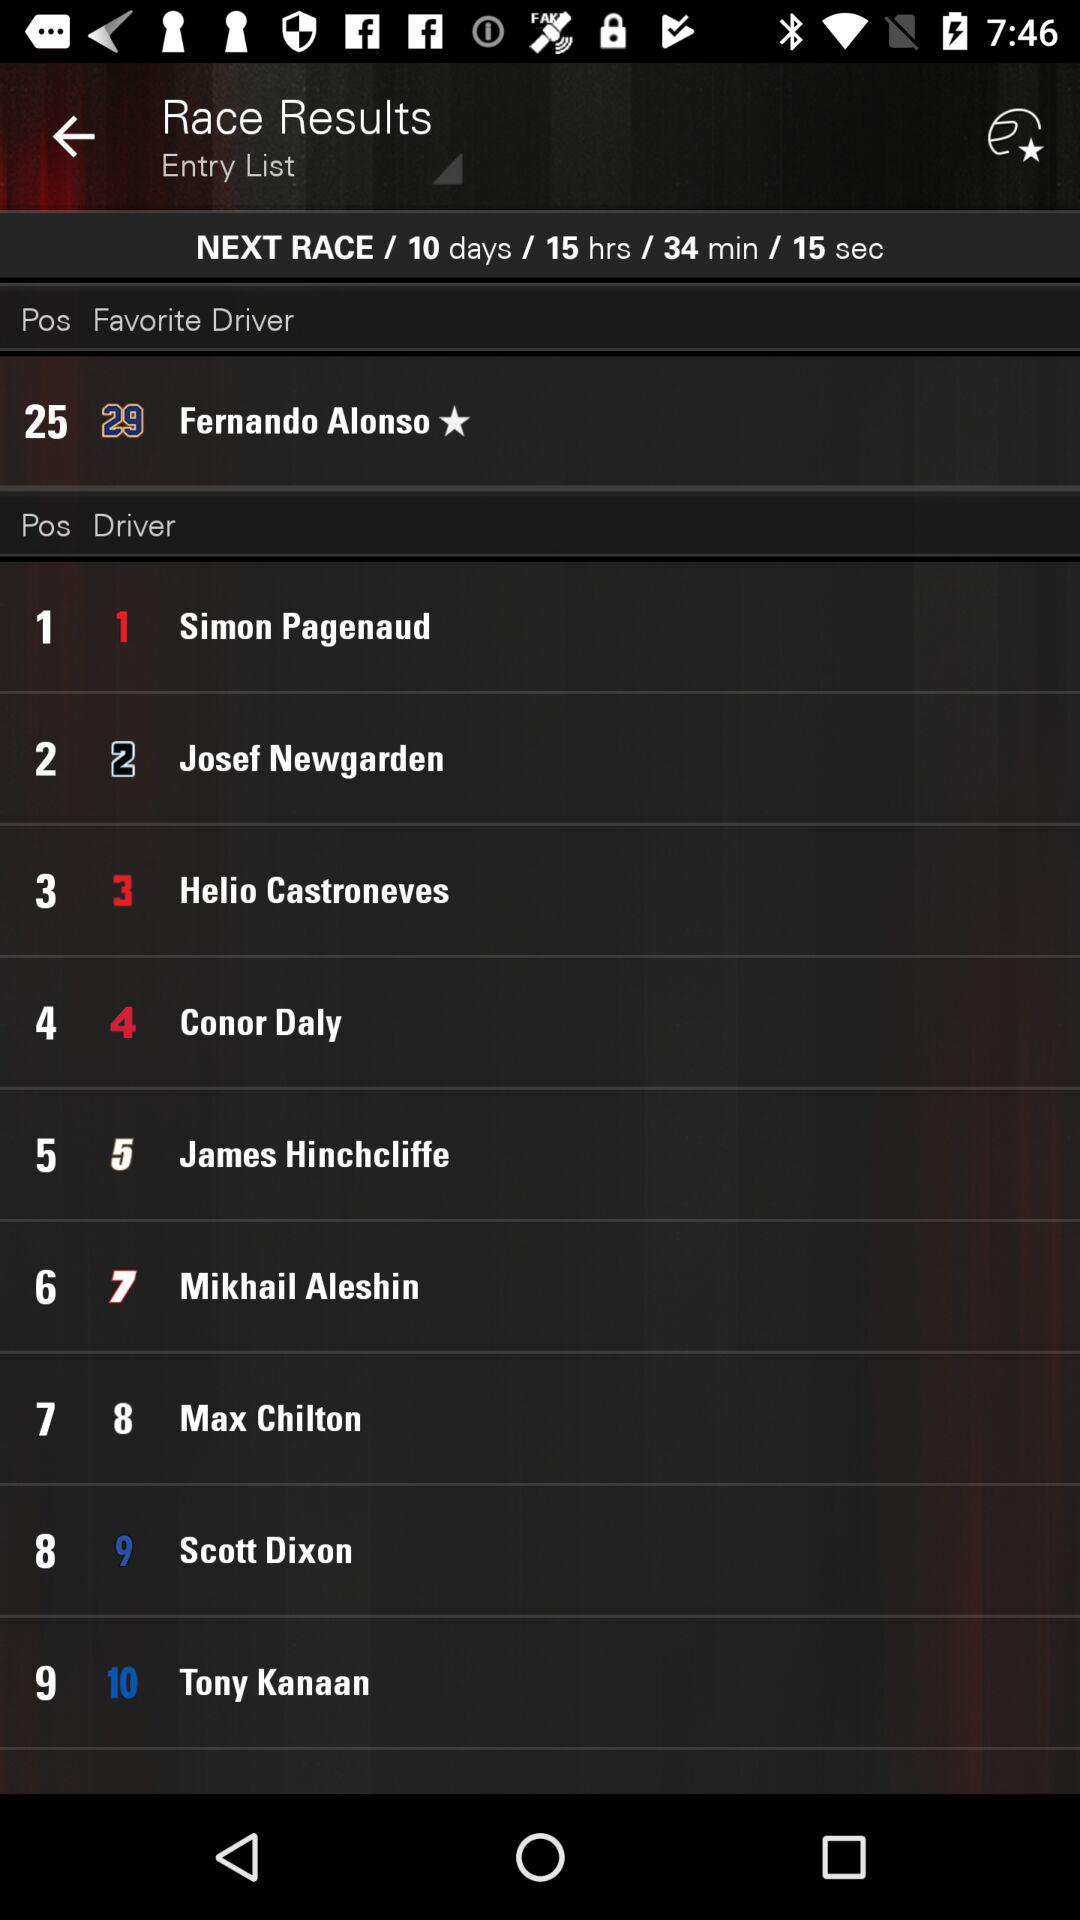How much time is left for the next race? The time left for the next race is 10 days 15 hours 34 minutes 15 seconds. 